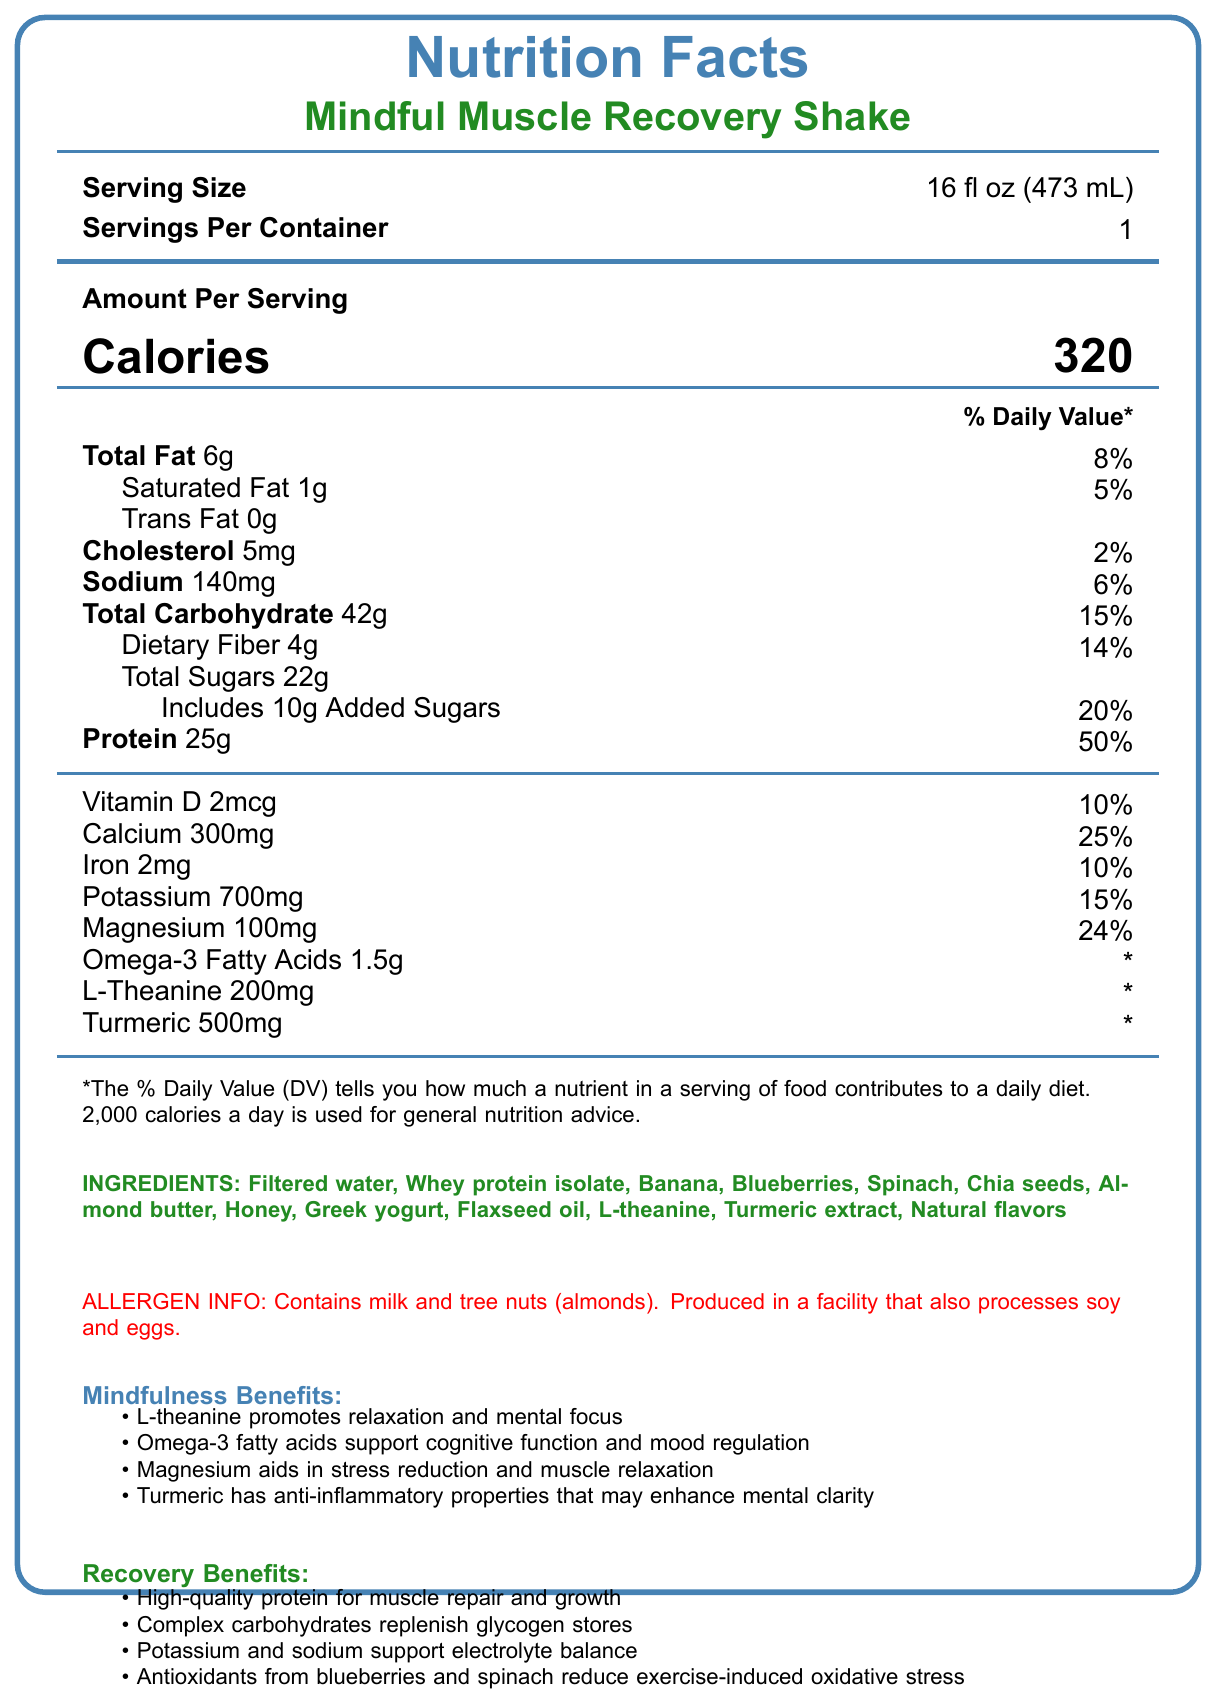what is the serving size? The serving size is explicitly mentioned as 16 fl oz (473 mL) in the document.
Answer: 16 fl oz (473 mL) how many calories are in one serving? The document states that there are 320 calories per serving.
Answer: 320 how much protein does one serving contain? The document specifies that there are 25g of protein in one serving.
Answer: 25g what is the daily value percentage of magnesium? The document indicates that one serving provides 24% of the daily value of magnesium.
Answer: 24% which allergens are mentioned in the document? The allergen information at the bottom of the document specifies milk and tree nuts (almonds).
Answer: Milk and tree nuts (almonds) how many grams of dietary fiber are there per serving? The dietary fiber content per serving is listed as 4g.
Answer: 4g which ingredient is responsible for promoting relaxation and mental focus? A. Whey protein isolate B. L-theanine C. Honey D. Blueberries According to the mindfulness benefits, L-theanine promotes relaxation and mental focus.
Answer: B what is the total amount of carbohydrates per serving? A. 22g B. 14g C. 42g D. 30g The total carbohydrate amount per serving is given as 42g.
Answer: C is the product free from trans fat? The document states that there is 0g of trans fat in the product.
Answer: Yes what are the main benefits of this shake for recovery? The recovery benefits section lists these benefits in detail.
Answer: High-quality protein for muscle repair and growth, complex carbohydrates to replenish glycogen stores, potassium and sodium to support electrolyte balance, antioxidants from blueberries and spinach to reduce exercise-induced oxidative stress how much omega-3 fatty acids does one serving provide? The omega-3 fatty acids amount per serving is stated as 1.5g in the document.
Answer: 1.5g based on the document, what are the mindfulness benefits of this shake? The document lists these benefits under the mindfulness benefits section.
Answer: L-theanine promotes relaxation and mental focus, omega-3 fatty acids support cognitive function and mood regulation, magnesium aids in stress reduction and muscle relaxation, turmeric has anti-inflammatory properties that may enhance mental clarity what is the daily value percentage of calcium in one serving? The document indicates that one serving contains 25% of the daily value for calcium.
Answer: 25% which nutrient helps with replenishing glycogen stores? The recovery benefits section mentions that complex carbohydrates help replenish glycogen stores.
Answer: Complex carbohydrates how many servings are there in one container? The document states that each container has 1 serving.
Answer: 1 what is one suggested way to consume this shake mindfully? The mindful consumption tip at the end of the document provides this suggestion.
Answer: Take a moment to express gratitude for your body's hard work before enjoying this nourishing shake. Sip slowly and mindfully, focusing on the flavors and the feeling of replenishing your body. what percentage of the daily value of sodium does one serving provide? The sodium content per serving is given as 140mg, which is 6% of the daily value.
Answer: 6% how much-added sugar does this shake contain? The document specifies that one serving includes 10g of added sugars.
Answer: 10g what are the main ingredients of this product? The ingredients list in the document provides all these components.
Answer: Filtered water, whey protein isolate, banana, blueberries, spinach, chia seeds, almond butter, honey, Greek yogurt, flaxseed oil, L-theanine, turmeric extract, natural flavors does the document provide any information about the vitamin C content? The document does not mention the vitamin C content at all.
Answer: No 